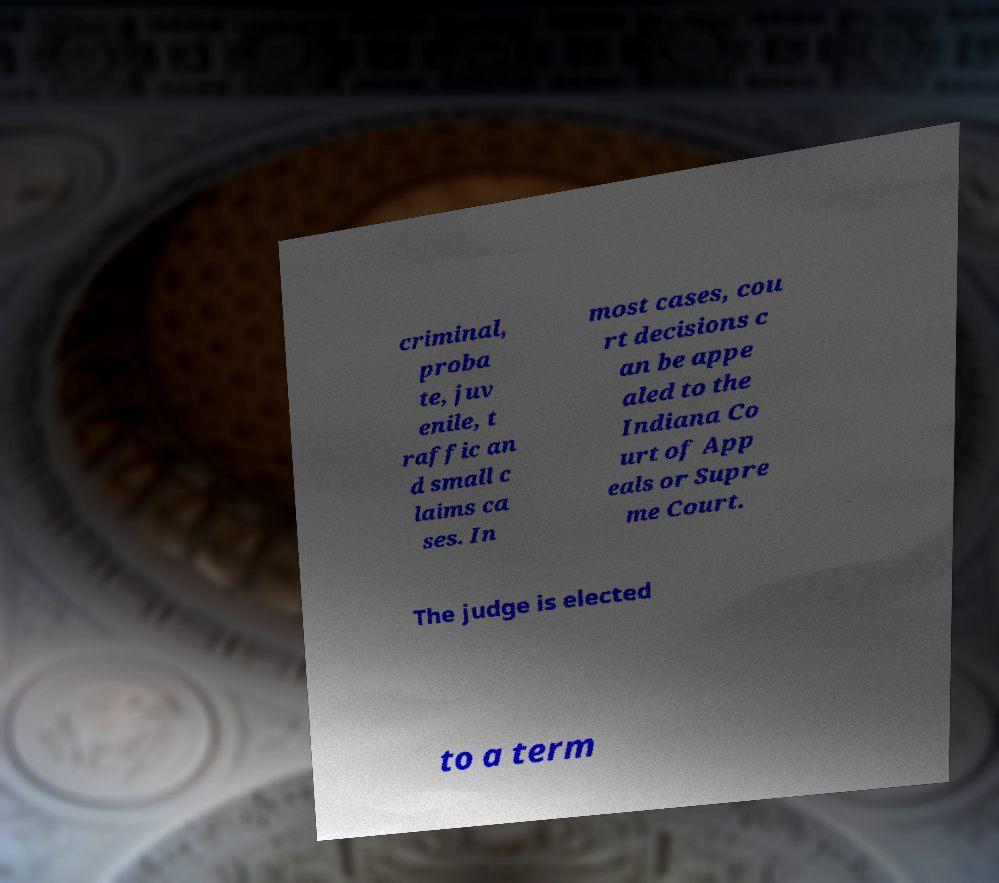Can you accurately transcribe the text from the provided image for me? criminal, proba te, juv enile, t raffic an d small c laims ca ses. In most cases, cou rt decisions c an be appe aled to the Indiana Co urt of App eals or Supre me Court. The judge is elected to a term 